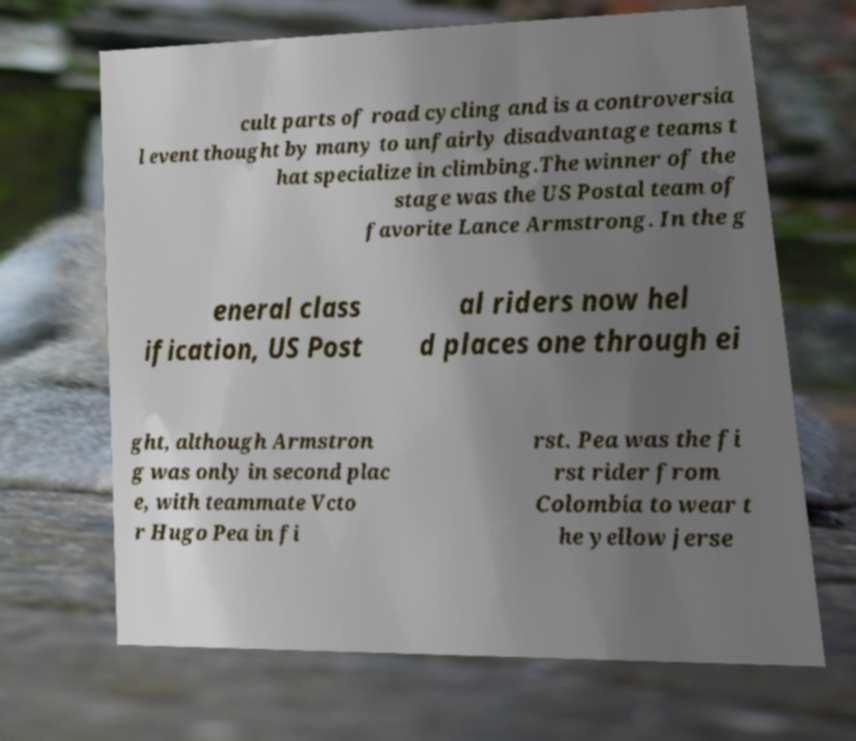Please read and relay the text visible in this image. What does it say? cult parts of road cycling and is a controversia l event thought by many to unfairly disadvantage teams t hat specialize in climbing.The winner of the stage was the US Postal team of favorite Lance Armstrong. In the g eneral class ification, US Post al riders now hel d places one through ei ght, although Armstron g was only in second plac e, with teammate Vcto r Hugo Pea in fi rst. Pea was the fi rst rider from Colombia to wear t he yellow jerse 